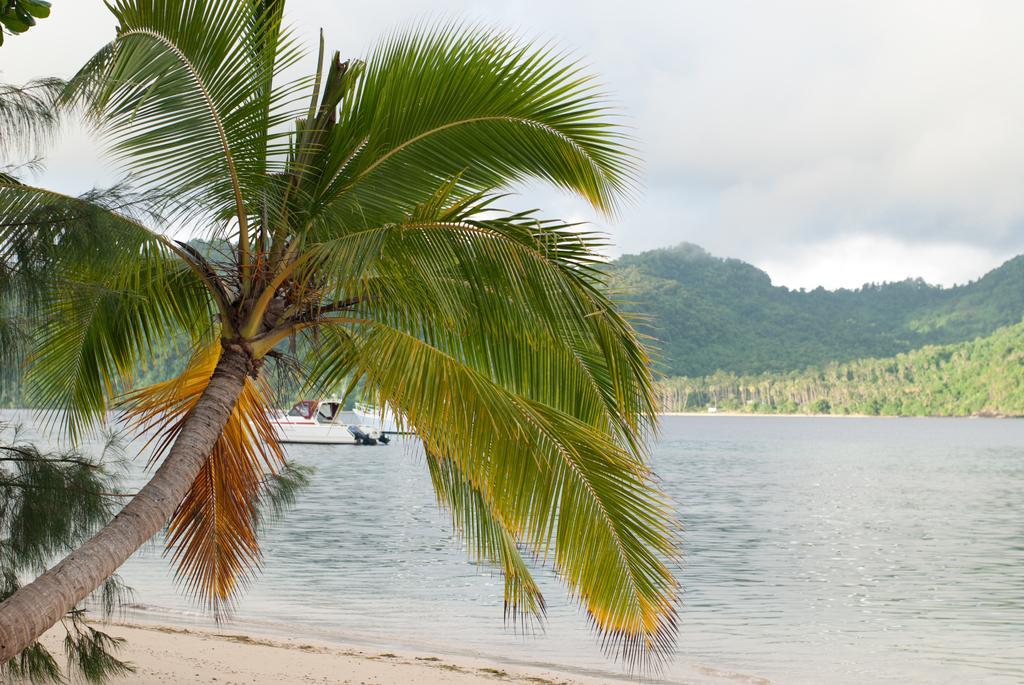Could you give a brief overview of what you see in this image? In this image we can see a boat on the surface of water. There is a tree on the left side of the image. In the background, we can see greenery. At the top of the image, the sky is covered with clouds. 